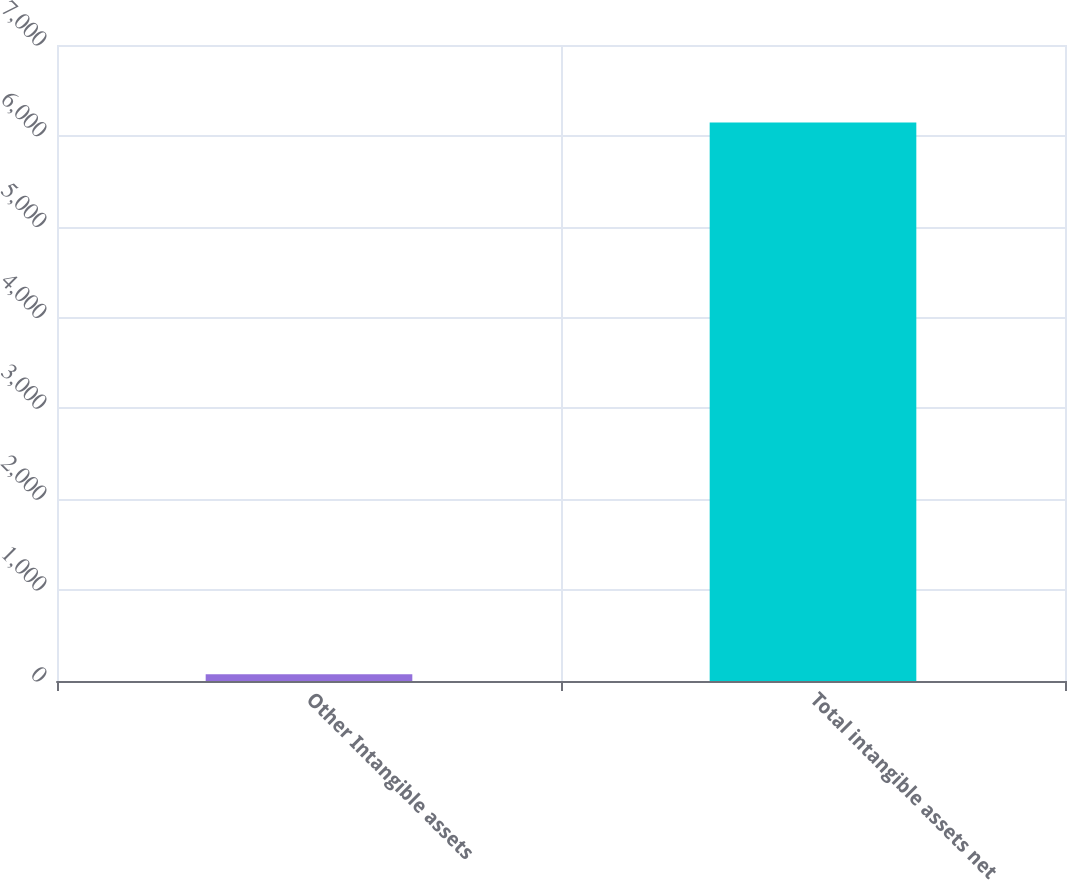Convert chart. <chart><loc_0><loc_0><loc_500><loc_500><bar_chart><fcel>Other Intangible assets<fcel>Total intangible assets net<nl><fcel>74<fcel>6148<nl></chart> 